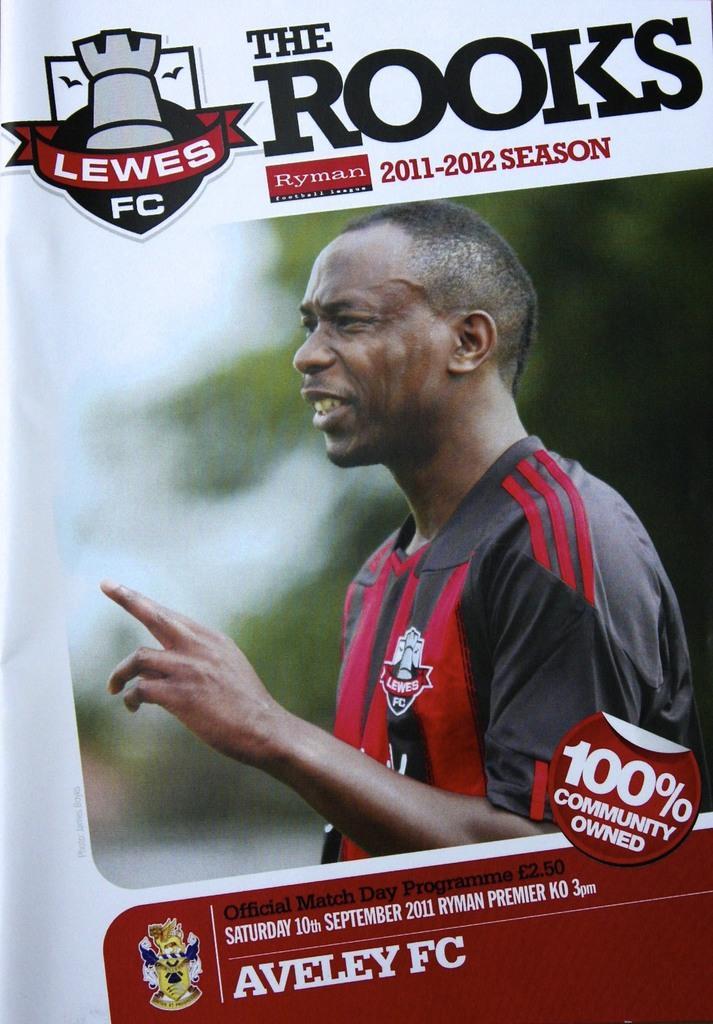Please provide a concise description of this image. In this picture, it seems like a poster, where we can see a man and text on it. 